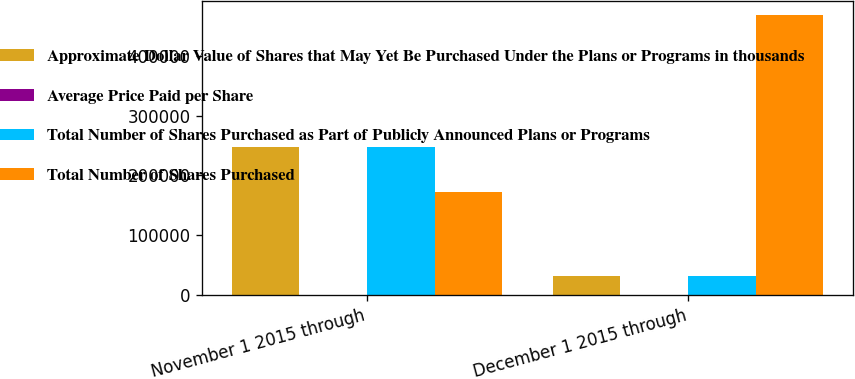<chart> <loc_0><loc_0><loc_500><loc_500><stacked_bar_chart><ecel><fcel>November 1 2015 through<fcel>December 1 2015 through<nl><fcel>Approximate Dollar Value of Shares that May Yet Be Purchased Under the Plans or Programs in thousands<fcel>248153<fcel>31300<nl><fcel>Average Price Paid per Share<fcel>73.1<fcel>73.98<nl><fcel>Total Number of Shares Purchased as Part of Publicly Announced Plans or Programs<fcel>248153<fcel>31300<nl><fcel>Total Number of Shares Purchased<fcel>171667<fcel>469351<nl></chart> 